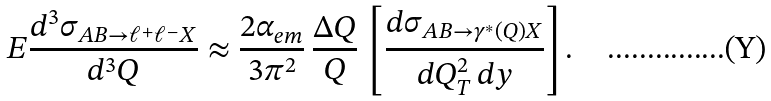<formula> <loc_0><loc_0><loc_500><loc_500>E \frac { d ^ { 3 } \sigma _ { A B \rightarrow \ell ^ { + } \ell ^ { - } X } } { d ^ { 3 } Q } \approx \frac { 2 \alpha _ { e m } } { 3 \pi ^ { 2 } } \, \frac { \Delta Q } { Q } \, \left [ \frac { d \sigma _ { A B \rightarrow \gamma ^ { * } ( Q ) X } } { d Q _ { T } ^ { 2 } \, d y } \right ] .</formula> 